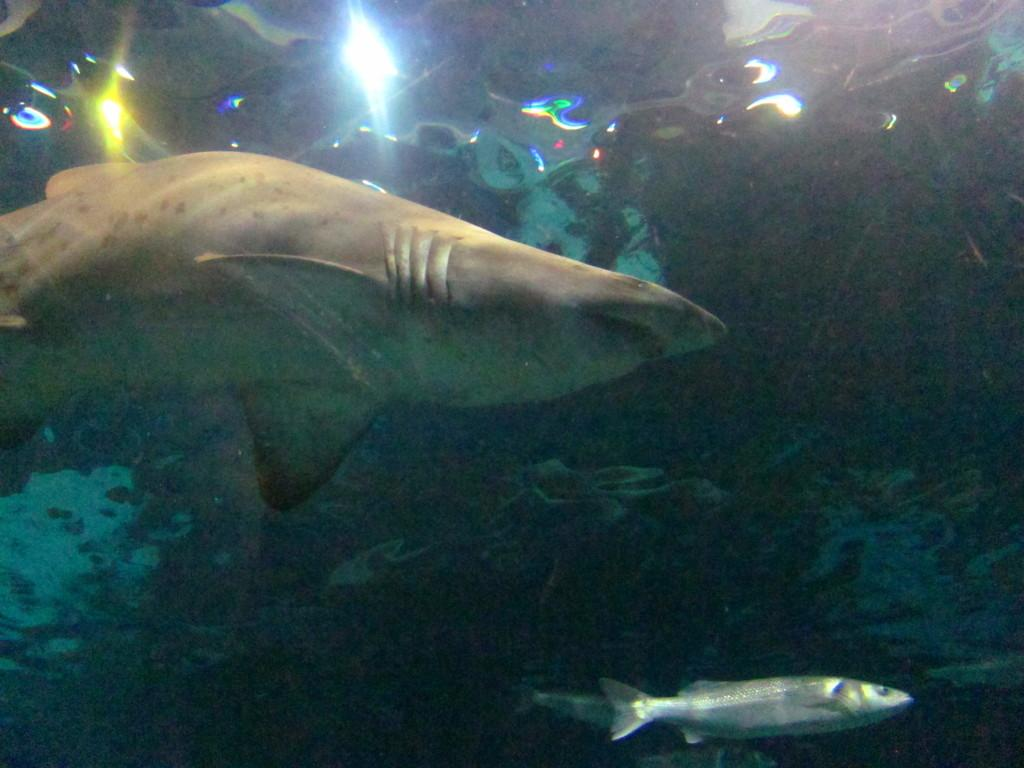What type of animals can be seen in the image? There are fishes in the image. What else is present in the water in the image? There are plants in the water in the image. What type of tool is being used to dig a plot in the image? There is no tool or digging activity present in the image; it features fishes and plants in the water. 